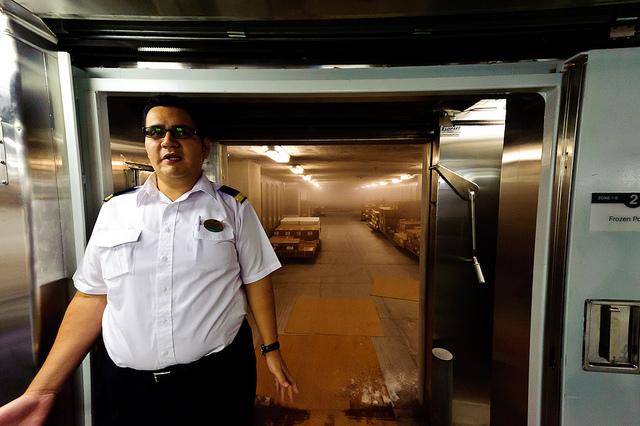How many people are in the foto?
Keep it brief. 1. Is the door behind the man open or closed?
Quick response, please. Open. Is he wearing sunglasses?
Quick response, please. Yes. Is this a pilot?
Be succinct. Yes. 